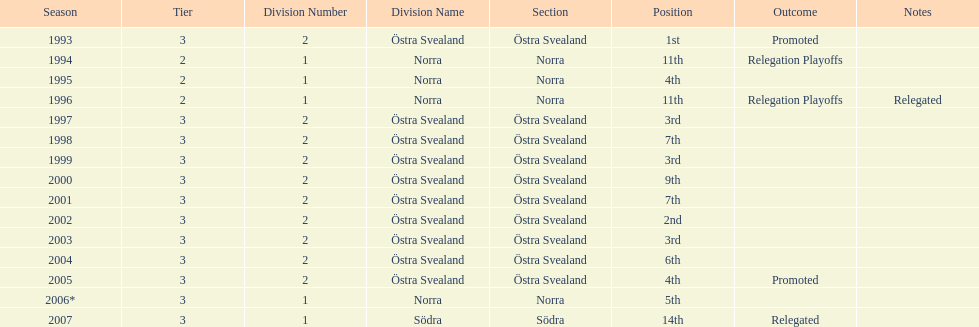How many times did they finish above 5th place in division 2 tier 3? 6. 